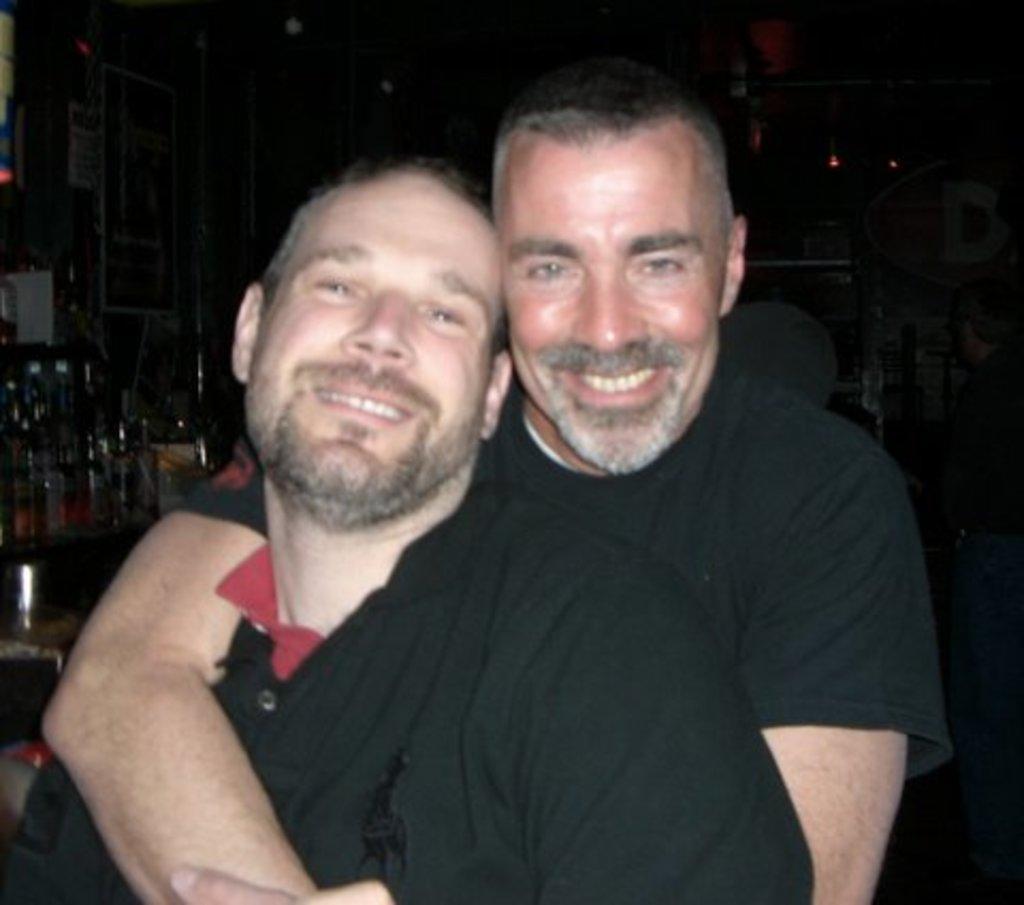Please provide a concise description of this image. In this image, we can see two persons wearing clothes. There are some bottles on the left side of the image. 